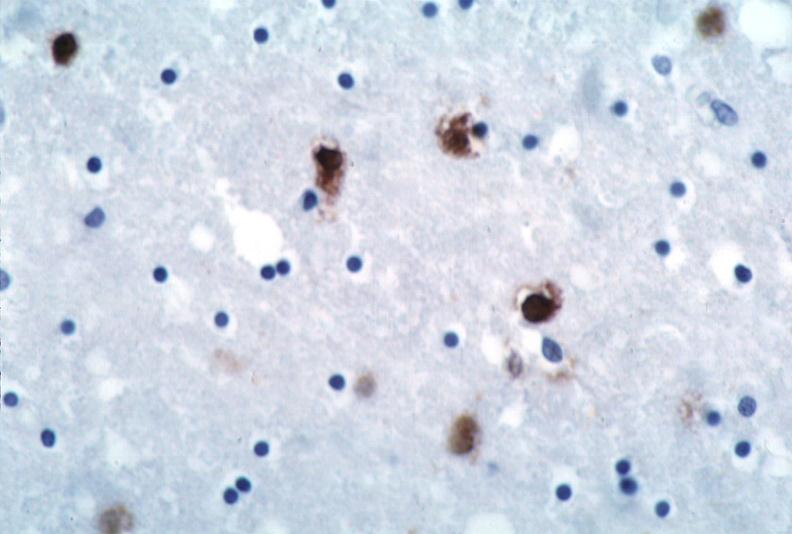what is present?
Answer the question using a single word or phrase. Nervous 